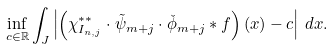<formula> <loc_0><loc_0><loc_500><loc_500>\inf _ { c \in \mathbb { R } } \int _ { J } \left | \left ( \chi ^ { * * } _ { I _ { n , j } } \cdot \tilde { \psi } _ { m + j } \cdot \check { \phi } _ { m + j } \ast f \right ) ( x ) - c \right | \, d x .</formula> 